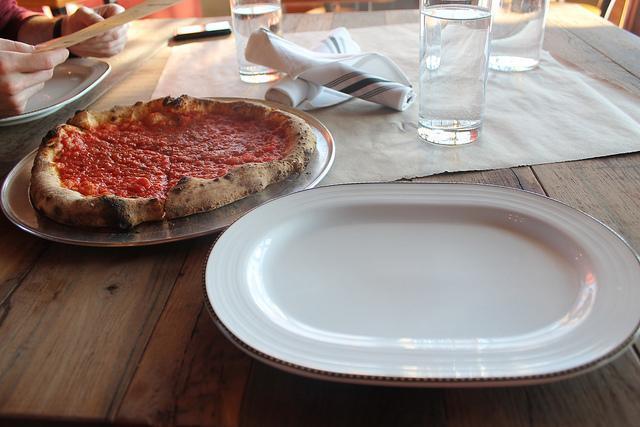Why is the plate empty?
Indicate the correct choice and explain in the format: 'Answer: answer
Rationale: rationale.'
Options: For customer, to throw, mistake, not hungry. Answer: for customer.
Rationale: The plate is for the customer. 